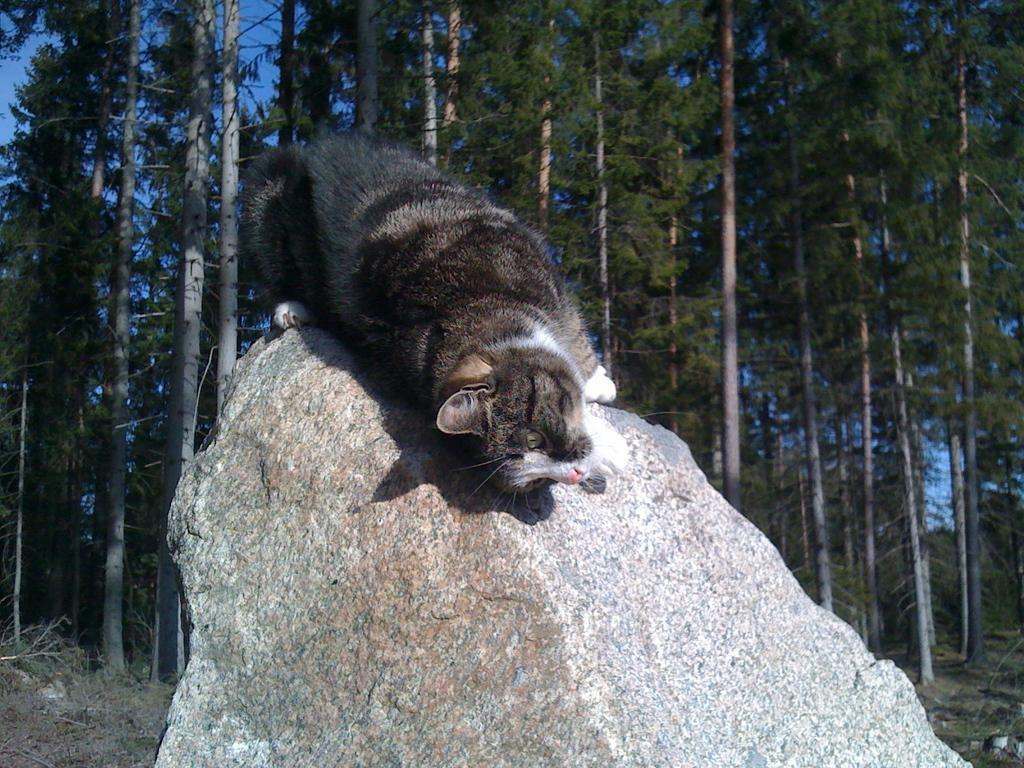What animal can be seen in the image? There is a cat in the image. Where is the cat sitting? The cat is sitting on a rock. What is the rock at the bottom of the image used for? The rock at the bottom of the image is a natural feature and not necessarily used for anything specific. What type of vegetation is visible in the background of the image? There are many trees in the background of the image. What is the ground made of at the bottom of the image? There is grass on the ground at the bottom of the image. What type of butter is being spread on the pump in the image? There is no butter or pump present in the image; it features a cat sitting on a rock with trees in the background. 